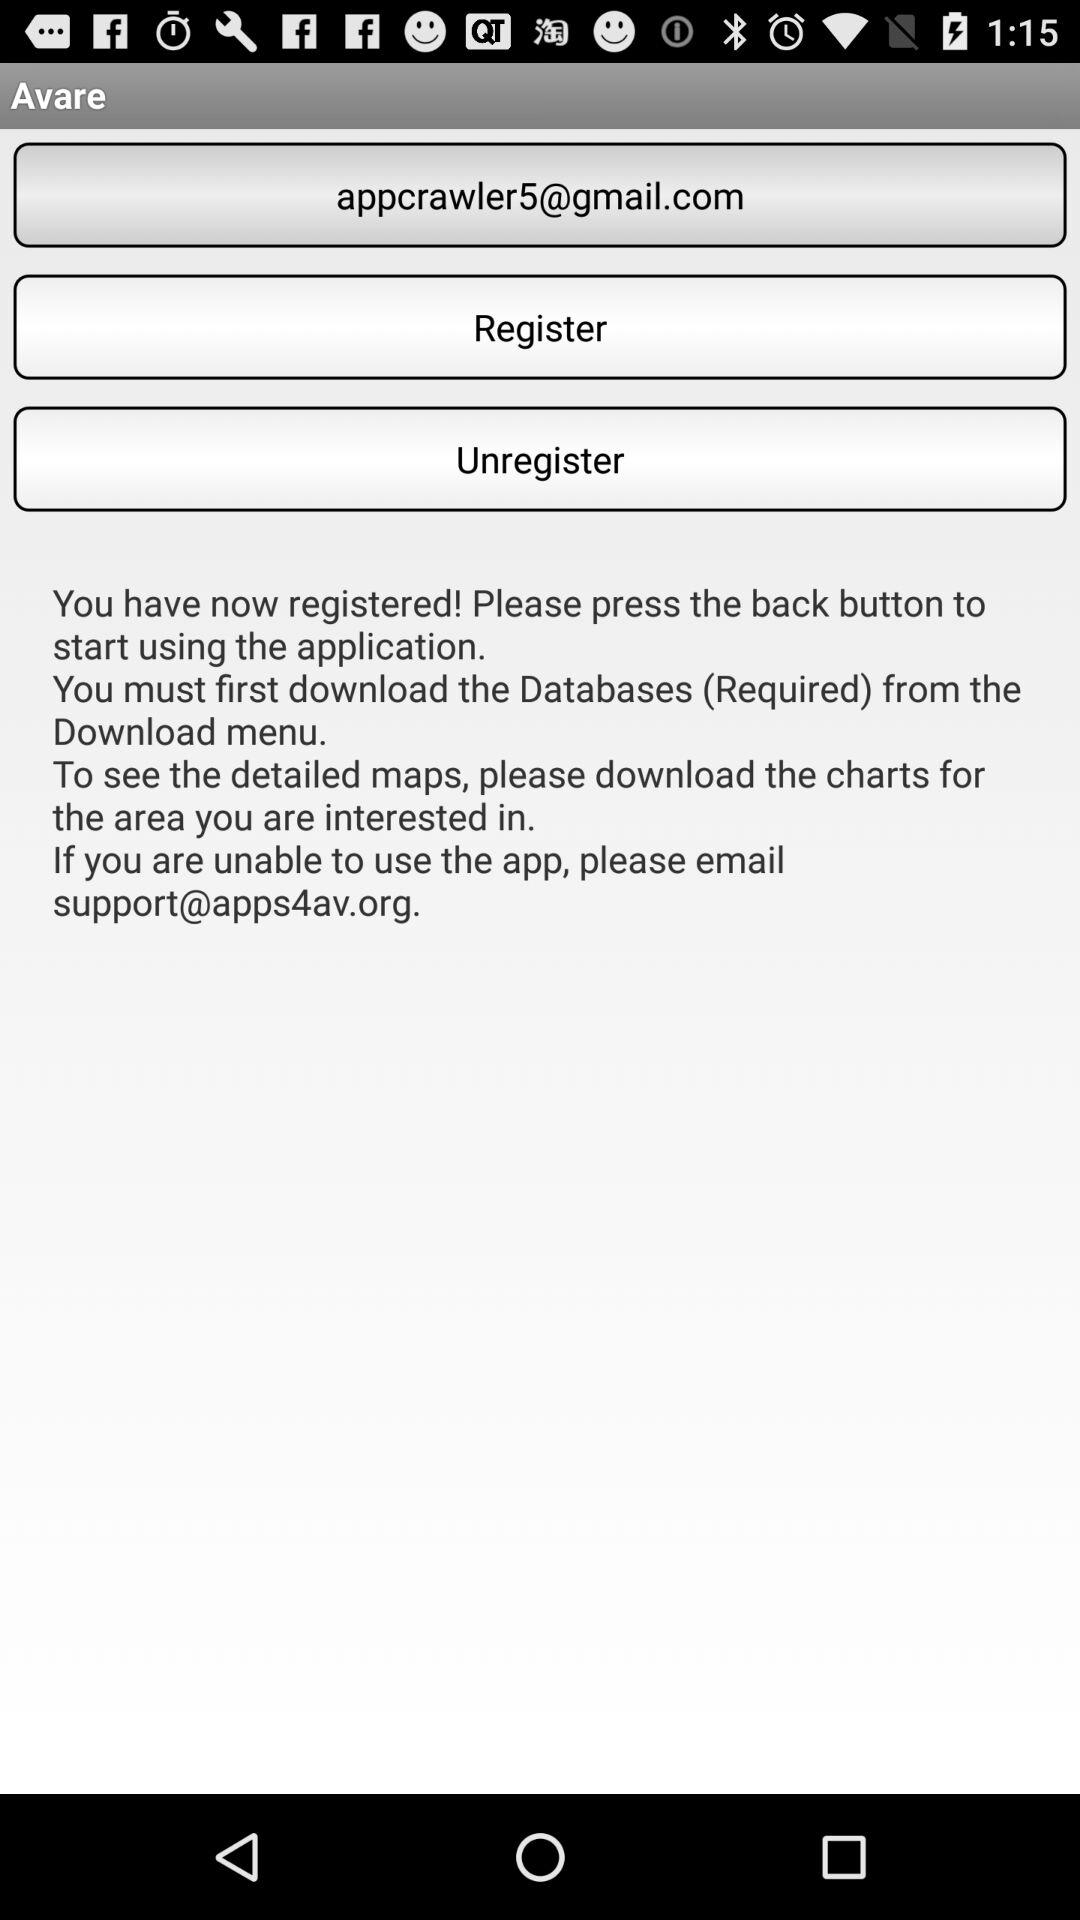What is the email address? The email address is appcrawler5@gmail.com. 